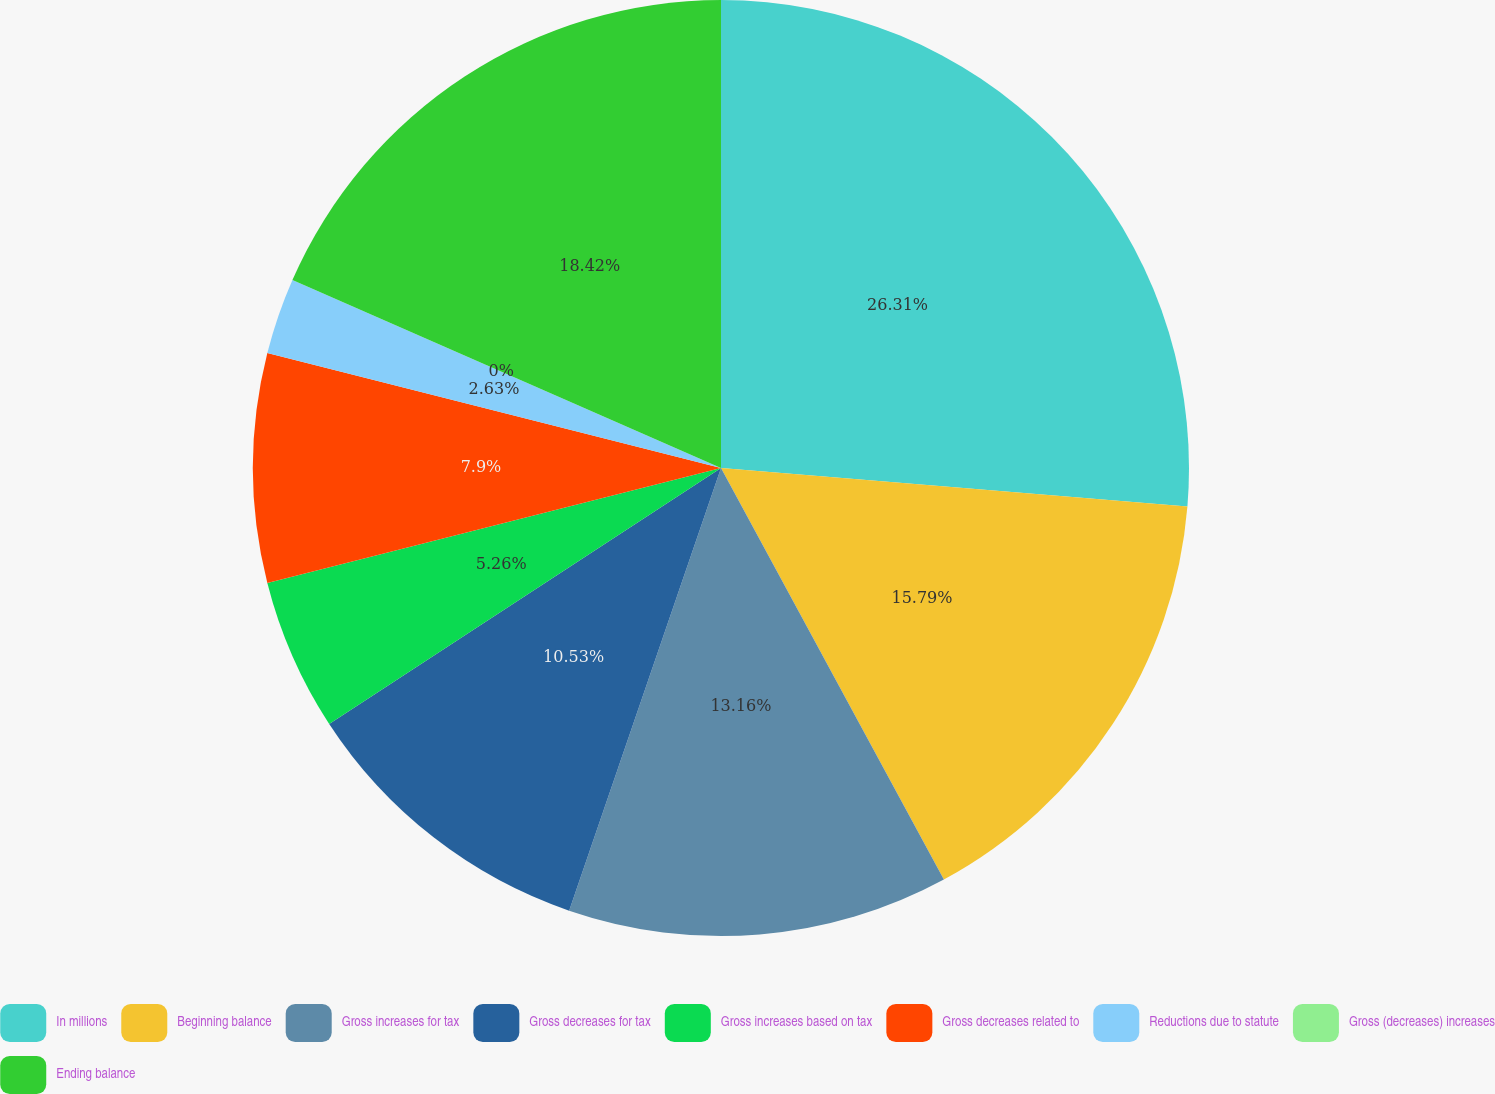Convert chart. <chart><loc_0><loc_0><loc_500><loc_500><pie_chart><fcel>In millions<fcel>Beginning balance<fcel>Gross increases for tax<fcel>Gross decreases for tax<fcel>Gross increases based on tax<fcel>Gross decreases related to<fcel>Reductions due to statute<fcel>Gross (decreases) increases<fcel>Ending balance<nl><fcel>26.31%<fcel>15.79%<fcel>13.16%<fcel>10.53%<fcel>5.26%<fcel>7.9%<fcel>2.63%<fcel>0.0%<fcel>18.42%<nl></chart> 